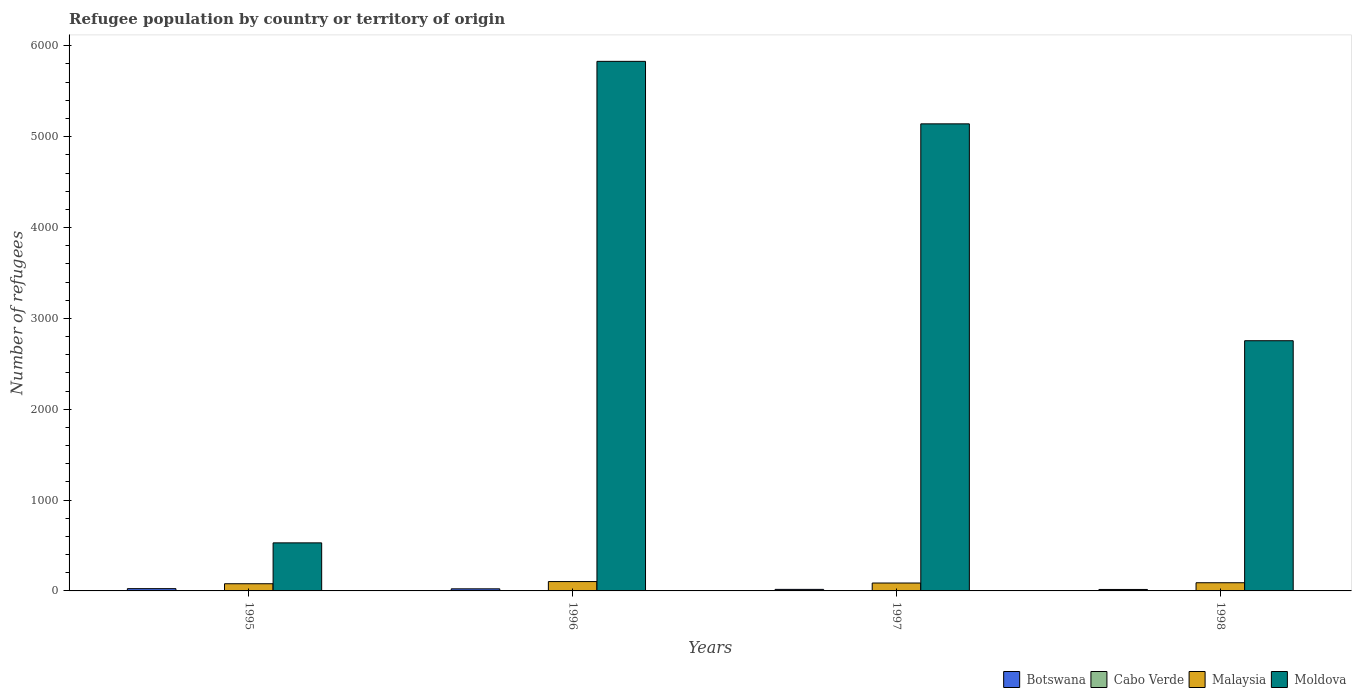How many different coloured bars are there?
Ensure brevity in your answer.  4. In how many cases, is the number of bars for a given year not equal to the number of legend labels?
Provide a succinct answer. 0. What is the number of refugees in Cabo Verde in 1997?
Provide a succinct answer. 2. Across all years, what is the maximum number of refugees in Cabo Verde?
Ensure brevity in your answer.  2. Across all years, what is the minimum number of refugees in Moldova?
Your answer should be very brief. 529. In which year was the number of refugees in Cabo Verde minimum?
Your response must be concise. 1995. What is the total number of refugees in Moldova in the graph?
Your answer should be very brief. 1.43e+04. What is the difference between the number of refugees in Botswana in 1997 and that in 1998?
Keep it short and to the point. 1. What is the difference between the number of refugees in Malaysia in 1998 and the number of refugees in Moldova in 1997?
Make the answer very short. -5051. What is the average number of refugees in Malaysia per year?
Make the answer very short. 89.75. In the year 1996, what is the difference between the number of refugees in Botswana and number of refugees in Moldova?
Offer a very short reply. -5806. In how many years, is the number of refugees in Moldova greater than 2800?
Provide a short and direct response. 2. What is the ratio of the number of refugees in Botswana in 1995 to that in 1997?
Offer a very short reply. 1.47. Is the difference between the number of refugees in Botswana in 1996 and 1997 greater than the difference between the number of refugees in Moldova in 1996 and 1997?
Make the answer very short. No. What is the difference between the highest and the second highest number of refugees in Botswana?
Your answer should be very brief. 2. What is the difference between the highest and the lowest number of refugees in Cabo Verde?
Your answer should be compact. 1. Is it the case that in every year, the sum of the number of refugees in Malaysia and number of refugees in Cabo Verde is greater than the sum of number of refugees in Moldova and number of refugees in Botswana?
Keep it short and to the point. No. What does the 4th bar from the left in 1995 represents?
Your answer should be compact. Moldova. What does the 4th bar from the right in 1997 represents?
Your response must be concise. Botswana. How many bars are there?
Offer a very short reply. 16. What is the difference between two consecutive major ticks on the Y-axis?
Your response must be concise. 1000. Does the graph contain grids?
Provide a succinct answer. No. Where does the legend appear in the graph?
Your answer should be very brief. Bottom right. How are the legend labels stacked?
Provide a succinct answer. Horizontal. What is the title of the graph?
Offer a terse response. Refugee population by country or territory of origin. What is the label or title of the X-axis?
Your response must be concise. Years. What is the label or title of the Y-axis?
Give a very brief answer. Number of refugees. What is the Number of refugees of Cabo Verde in 1995?
Give a very brief answer. 1. What is the Number of refugees of Malaysia in 1995?
Ensure brevity in your answer.  79. What is the Number of refugees in Moldova in 1995?
Keep it short and to the point. 529. What is the Number of refugees in Malaysia in 1996?
Make the answer very short. 103. What is the Number of refugees in Moldova in 1996?
Provide a short and direct response. 5829. What is the Number of refugees in Botswana in 1997?
Offer a terse response. 17. What is the Number of refugees of Malaysia in 1997?
Give a very brief answer. 87. What is the Number of refugees in Moldova in 1997?
Keep it short and to the point. 5141. What is the Number of refugees of Malaysia in 1998?
Your answer should be compact. 90. What is the Number of refugees in Moldova in 1998?
Your response must be concise. 2754. Across all years, what is the maximum Number of refugees in Botswana?
Your response must be concise. 25. Across all years, what is the maximum Number of refugees of Malaysia?
Make the answer very short. 103. Across all years, what is the maximum Number of refugees in Moldova?
Keep it short and to the point. 5829. Across all years, what is the minimum Number of refugees of Cabo Verde?
Give a very brief answer. 1. Across all years, what is the minimum Number of refugees in Malaysia?
Your answer should be very brief. 79. Across all years, what is the minimum Number of refugees in Moldova?
Ensure brevity in your answer.  529. What is the total Number of refugees of Malaysia in the graph?
Make the answer very short. 359. What is the total Number of refugees of Moldova in the graph?
Offer a very short reply. 1.43e+04. What is the difference between the Number of refugees in Malaysia in 1995 and that in 1996?
Offer a terse response. -24. What is the difference between the Number of refugees of Moldova in 1995 and that in 1996?
Keep it short and to the point. -5300. What is the difference between the Number of refugees of Botswana in 1995 and that in 1997?
Offer a terse response. 8. What is the difference between the Number of refugees of Malaysia in 1995 and that in 1997?
Ensure brevity in your answer.  -8. What is the difference between the Number of refugees of Moldova in 1995 and that in 1997?
Keep it short and to the point. -4612. What is the difference between the Number of refugees in Cabo Verde in 1995 and that in 1998?
Make the answer very short. 0. What is the difference between the Number of refugees of Moldova in 1995 and that in 1998?
Provide a succinct answer. -2225. What is the difference between the Number of refugees of Moldova in 1996 and that in 1997?
Your answer should be very brief. 688. What is the difference between the Number of refugees in Botswana in 1996 and that in 1998?
Give a very brief answer. 7. What is the difference between the Number of refugees in Malaysia in 1996 and that in 1998?
Make the answer very short. 13. What is the difference between the Number of refugees of Moldova in 1996 and that in 1998?
Provide a succinct answer. 3075. What is the difference between the Number of refugees of Botswana in 1997 and that in 1998?
Your response must be concise. 1. What is the difference between the Number of refugees of Malaysia in 1997 and that in 1998?
Give a very brief answer. -3. What is the difference between the Number of refugees in Moldova in 1997 and that in 1998?
Keep it short and to the point. 2387. What is the difference between the Number of refugees of Botswana in 1995 and the Number of refugees of Malaysia in 1996?
Offer a very short reply. -78. What is the difference between the Number of refugees in Botswana in 1995 and the Number of refugees in Moldova in 1996?
Offer a terse response. -5804. What is the difference between the Number of refugees in Cabo Verde in 1995 and the Number of refugees in Malaysia in 1996?
Keep it short and to the point. -102. What is the difference between the Number of refugees of Cabo Verde in 1995 and the Number of refugees of Moldova in 1996?
Your answer should be very brief. -5828. What is the difference between the Number of refugees in Malaysia in 1995 and the Number of refugees in Moldova in 1996?
Your answer should be compact. -5750. What is the difference between the Number of refugees of Botswana in 1995 and the Number of refugees of Malaysia in 1997?
Offer a terse response. -62. What is the difference between the Number of refugees in Botswana in 1995 and the Number of refugees in Moldova in 1997?
Offer a terse response. -5116. What is the difference between the Number of refugees of Cabo Verde in 1995 and the Number of refugees of Malaysia in 1997?
Your answer should be compact. -86. What is the difference between the Number of refugees in Cabo Verde in 1995 and the Number of refugees in Moldova in 1997?
Give a very brief answer. -5140. What is the difference between the Number of refugees of Malaysia in 1995 and the Number of refugees of Moldova in 1997?
Give a very brief answer. -5062. What is the difference between the Number of refugees in Botswana in 1995 and the Number of refugees in Malaysia in 1998?
Provide a succinct answer. -65. What is the difference between the Number of refugees of Botswana in 1995 and the Number of refugees of Moldova in 1998?
Give a very brief answer. -2729. What is the difference between the Number of refugees of Cabo Verde in 1995 and the Number of refugees of Malaysia in 1998?
Offer a very short reply. -89. What is the difference between the Number of refugees in Cabo Verde in 1995 and the Number of refugees in Moldova in 1998?
Make the answer very short. -2753. What is the difference between the Number of refugees of Malaysia in 1995 and the Number of refugees of Moldova in 1998?
Offer a terse response. -2675. What is the difference between the Number of refugees of Botswana in 1996 and the Number of refugees of Cabo Verde in 1997?
Give a very brief answer. 21. What is the difference between the Number of refugees of Botswana in 1996 and the Number of refugees of Malaysia in 1997?
Provide a succinct answer. -64. What is the difference between the Number of refugees in Botswana in 1996 and the Number of refugees in Moldova in 1997?
Provide a succinct answer. -5118. What is the difference between the Number of refugees in Cabo Verde in 1996 and the Number of refugees in Malaysia in 1997?
Ensure brevity in your answer.  -85. What is the difference between the Number of refugees in Cabo Verde in 1996 and the Number of refugees in Moldova in 1997?
Give a very brief answer. -5139. What is the difference between the Number of refugees of Malaysia in 1996 and the Number of refugees of Moldova in 1997?
Offer a very short reply. -5038. What is the difference between the Number of refugees of Botswana in 1996 and the Number of refugees of Cabo Verde in 1998?
Provide a succinct answer. 22. What is the difference between the Number of refugees in Botswana in 1996 and the Number of refugees in Malaysia in 1998?
Offer a terse response. -67. What is the difference between the Number of refugees of Botswana in 1996 and the Number of refugees of Moldova in 1998?
Keep it short and to the point. -2731. What is the difference between the Number of refugees of Cabo Verde in 1996 and the Number of refugees of Malaysia in 1998?
Provide a short and direct response. -88. What is the difference between the Number of refugees in Cabo Verde in 1996 and the Number of refugees in Moldova in 1998?
Keep it short and to the point. -2752. What is the difference between the Number of refugees of Malaysia in 1996 and the Number of refugees of Moldova in 1998?
Ensure brevity in your answer.  -2651. What is the difference between the Number of refugees of Botswana in 1997 and the Number of refugees of Cabo Verde in 1998?
Provide a short and direct response. 16. What is the difference between the Number of refugees in Botswana in 1997 and the Number of refugees in Malaysia in 1998?
Provide a succinct answer. -73. What is the difference between the Number of refugees in Botswana in 1997 and the Number of refugees in Moldova in 1998?
Keep it short and to the point. -2737. What is the difference between the Number of refugees of Cabo Verde in 1997 and the Number of refugees of Malaysia in 1998?
Offer a terse response. -88. What is the difference between the Number of refugees in Cabo Verde in 1997 and the Number of refugees in Moldova in 1998?
Provide a succinct answer. -2752. What is the difference between the Number of refugees in Malaysia in 1997 and the Number of refugees in Moldova in 1998?
Provide a succinct answer. -2667. What is the average Number of refugees in Botswana per year?
Your response must be concise. 20.25. What is the average Number of refugees of Malaysia per year?
Your answer should be compact. 89.75. What is the average Number of refugees in Moldova per year?
Provide a short and direct response. 3563.25. In the year 1995, what is the difference between the Number of refugees of Botswana and Number of refugees of Malaysia?
Make the answer very short. -54. In the year 1995, what is the difference between the Number of refugees in Botswana and Number of refugees in Moldova?
Your response must be concise. -504. In the year 1995, what is the difference between the Number of refugees in Cabo Verde and Number of refugees in Malaysia?
Keep it short and to the point. -78. In the year 1995, what is the difference between the Number of refugees in Cabo Verde and Number of refugees in Moldova?
Provide a succinct answer. -528. In the year 1995, what is the difference between the Number of refugees of Malaysia and Number of refugees of Moldova?
Provide a succinct answer. -450. In the year 1996, what is the difference between the Number of refugees in Botswana and Number of refugees in Malaysia?
Provide a short and direct response. -80. In the year 1996, what is the difference between the Number of refugees of Botswana and Number of refugees of Moldova?
Provide a succinct answer. -5806. In the year 1996, what is the difference between the Number of refugees in Cabo Verde and Number of refugees in Malaysia?
Provide a short and direct response. -101. In the year 1996, what is the difference between the Number of refugees in Cabo Verde and Number of refugees in Moldova?
Make the answer very short. -5827. In the year 1996, what is the difference between the Number of refugees of Malaysia and Number of refugees of Moldova?
Make the answer very short. -5726. In the year 1997, what is the difference between the Number of refugees of Botswana and Number of refugees of Malaysia?
Ensure brevity in your answer.  -70. In the year 1997, what is the difference between the Number of refugees of Botswana and Number of refugees of Moldova?
Make the answer very short. -5124. In the year 1997, what is the difference between the Number of refugees of Cabo Verde and Number of refugees of Malaysia?
Make the answer very short. -85. In the year 1997, what is the difference between the Number of refugees in Cabo Verde and Number of refugees in Moldova?
Your answer should be compact. -5139. In the year 1997, what is the difference between the Number of refugees of Malaysia and Number of refugees of Moldova?
Offer a terse response. -5054. In the year 1998, what is the difference between the Number of refugees of Botswana and Number of refugees of Malaysia?
Ensure brevity in your answer.  -74. In the year 1998, what is the difference between the Number of refugees in Botswana and Number of refugees in Moldova?
Your response must be concise. -2738. In the year 1998, what is the difference between the Number of refugees of Cabo Verde and Number of refugees of Malaysia?
Give a very brief answer. -89. In the year 1998, what is the difference between the Number of refugees in Cabo Verde and Number of refugees in Moldova?
Provide a succinct answer. -2753. In the year 1998, what is the difference between the Number of refugees in Malaysia and Number of refugees in Moldova?
Keep it short and to the point. -2664. What is the ratio of the Number of refugees of Botswana in 1995 to that in 1996?
Keep it short and to the point. 1.09. What is the ratio of the Number of refugees of Cabo Verde in 1995 to that in 1996?
Provide a succinct answer. 0.5. What is the ratio of the Number of refugees in Malaysia in 1995 to that in 1996?
Give a very brief answer. 0.77. What is the ratio of the Number of refugees of Moldova in 1995 to that in 1996?
Make the answer very short. 0.09. What is the ratio of the Number of refugees in Botswana in 1995 to that in 1997?
Offer a very short reply. 1.47. What is the ratio of the Number of refugees of Malaysia in 1995 to that in 1997?
Give a very brief answer. 0.91. What is the ratio of the Number of refugees of Moldova in 1995 to that in 1997?
Provide a succinct answer. 0.1. What is the ratio of the Number of refugees of Botswana in 1995 to that in 1998?
Your response must be concise. 1.56. What is the ratio of the Number of refugees of Cabo Verde in 1995 to that in 1998?
Offer a very short reply. 1. What is the ratio of the Number of refugees of Malaysia in 1995 to that in 1998?
Provide a succinct answer. 0.88. What is the ratio of the Number of refugees in Moldova in 1995 to that in 1998?
Offer a very short reply. 0.19. What is the ratio of the Number of refugees in Botswana in 1996 to that in 1997?
Give a very brief answer. 1.35. What is the ratio of the Number of refugees of Cabo Verde in 1996 to that in 1997?
Offer a very short reply. 1. What is the ratio of the Number of refugees of Malaysia in 1996 to that in 1997?
Ensure brevity in your answer.  1.18. What is the ratio of the Number of refugees of Moldova in 1996 to that in 1997?
Make the answer very short. 1.13. What is the ratio of the Number of refugees of Botswana in 1996 to that in 1998?
Ensure brevity in your answer.  1.44. What is the ratio of the Number of refugees of Malaysia in 1996 to that in 1998?
Make the answer very short. 1.14. What is the ratio of the Number of refugees of Moldova in 1996 to that in 1998?
Your response must be concise. 2.12. What is the ratio of the Number of refugees in Malaysia in 1997 to that in 1998?
Give a very brief answer. 0.97. What is the ratio of the Number of refugees in Moldova in 1997 to that in 1998?
Offer a terse response. 1.87. What is the difference between the highest and the second highest Number of refugees of Botswana?
Ensure brevity in your answer.  2. What is the difference between the highest and the second highest Number of refugees of Cabo Verde?
Offer a very short reply. 0. What is the difference between the highest and the second highest Number of refugees in Malaysia?
Provide a short and direct response. 13. What is the difference between the highest and the second highest Number of refugees of Moldova?
Offer a terse response. 688. What is the difference between the highest and the lowest Number of refugees of Cabo Verde?
Your response must be concise. 1. What is the difference between the highest and the lowest Number of refugees in Malaysia?
Offer a terse response. 24. What is the difference between the highest and the lowest Number of refugees of Moldova?
Provide a succinct answer. 5300. 